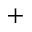<formula> <loc_0><loc_0><loc_500><loc_500>^ { + }</formula> 